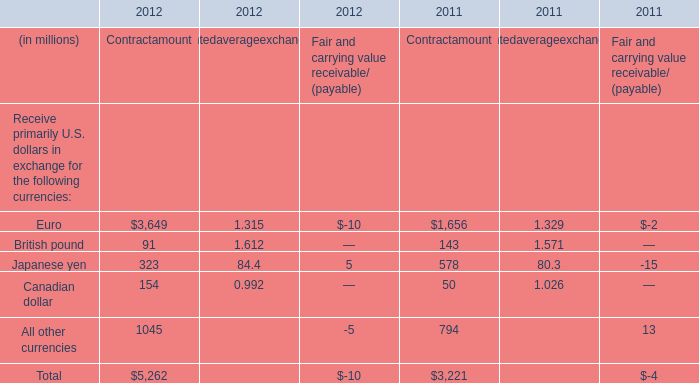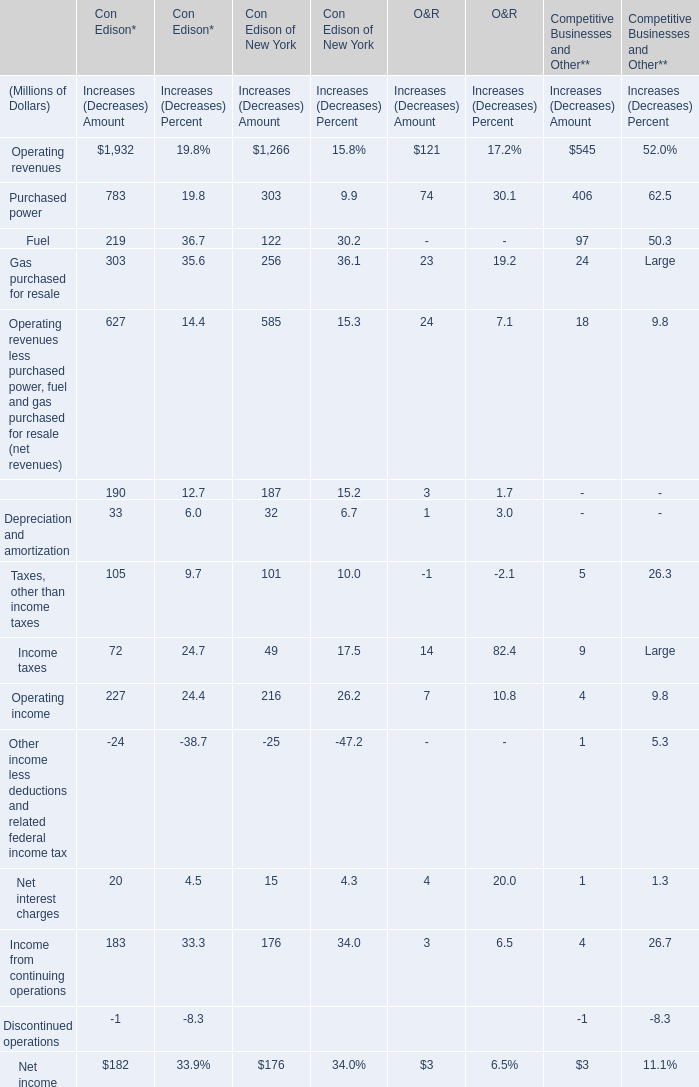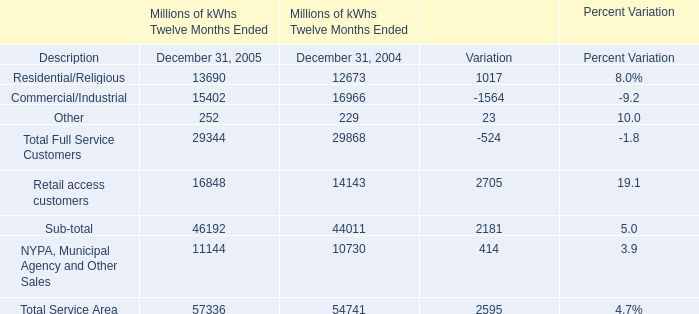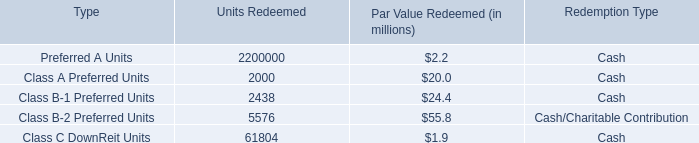In the year with largest amount of Total Service Area, what's the increasing rate of NYPA, Municipal Agency and Other Sales? 
Computations: ((11144 - 10730) / 10730)
Answer: 0.03858. 